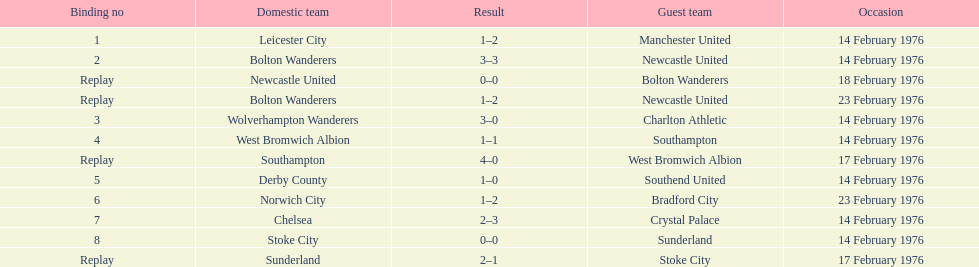How many teams played on february 14th, 1976? 7. 